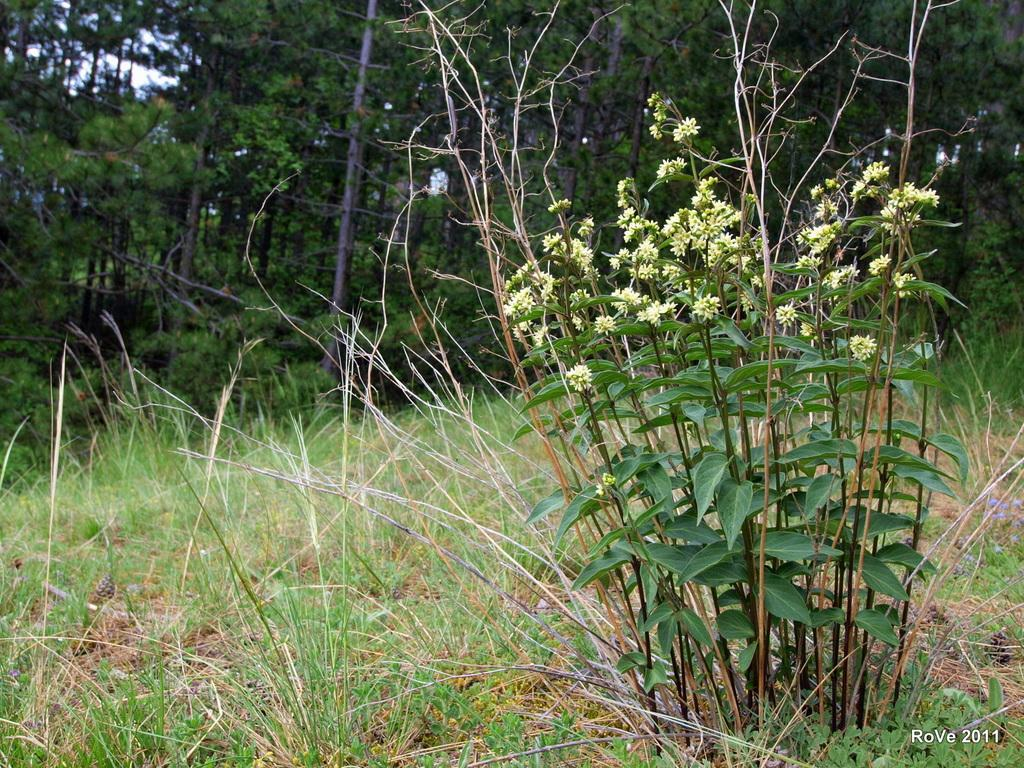What type of vegetation can be seen on the right side of the image? There are plants with small flowers on the right side of the image. What is covering the ground at the bottom of the image? There is grass on the ground at the bottom of the image. What can be seen in the background of the image? There are trees and the sky visible in the background of the image. What type of eggnog can be seen in the image? There is no eggnog present in the image. What is the texture of the mailbox in the image? There is no mailbox present in the image. 